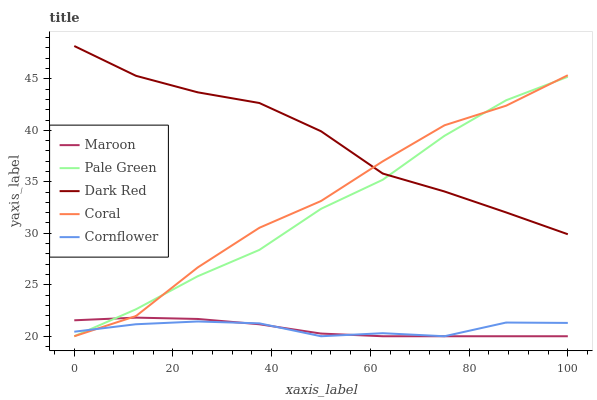Does Maroon have the minimum area under the curve?
Answer yes or no. Yes. Does Dark Red have the maximum area under the curve?
Answer yes or no. Yes. Does Coral have the minimum area under the curve?
Answer yes or no. No. Does Coral have the maximum area under the curve?
Answer yes or no. No. Is Maroon the smoothest?
Answer yes or no. Yes. Is Coral the roughest?
Answer yes or no. Yes. Is Pale Green the smoothest?
Answer yes or no. No. Is Pale Green the roughest?
Answer yes or no. No. Does Coral have the lowest value?
Answer yes or no. Yes. Does Dark Red have the highest value?
Answer yes or no. Yes. Does Coral have the highest value?
Answer yes or no. No. Is Maroon less than Dark Red?
Answer yes or no. Yes. Is Dark Red greater than Cornflower?
Answer yes or no. Yes. Does Cornflower intersect Pale Green?
Answer yes or no. Yes. Is Cornflower less than Pale Green?
Answer yes or no. No. Is Cornflower greater than Pale Green?
Answer yes or no. No. Does Maroon intersect Dark Red?
Answer yes or no. No. 